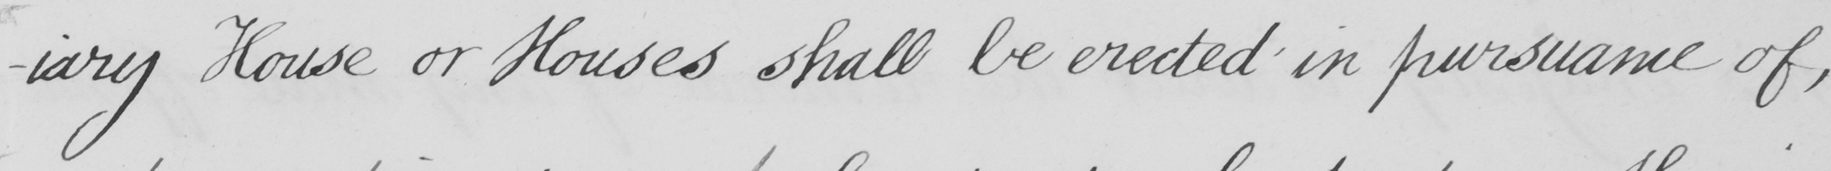What text is written in this handwritten line? -iary House or Houses shall be erected in pursuance of , 